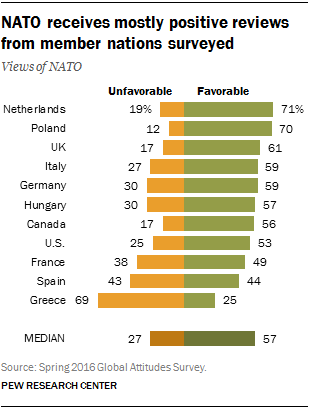Identify some key points in this picture. The median of the favorable responses was 0.57. The difference between the UK's favorable rating and the median rating is 0.04 points. 